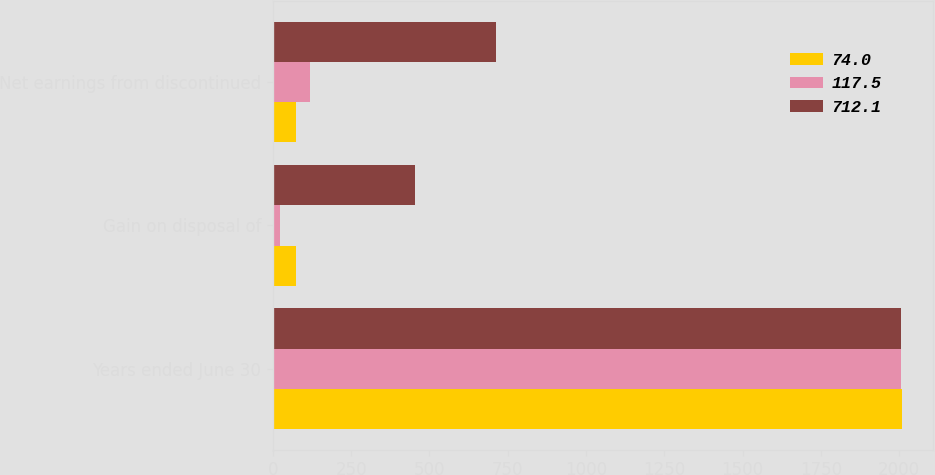<chart> <loc_0><loc_0><loc_500><loc_500><stacked_bar_chart><ecel><fcel>Years ended June 30<fcel>Gain on disposal of<fcel>Net earnings from discontinued<nl><fcel>74<fcel>2008<fcel>74<fcel>74<nl><fcel>117.5<fcel>2007<fcel>20.9<fcel>117.5<nl><fcel>712.1<fcel>2006<fcel>452.8<fcel>712.1<nl></chart> 